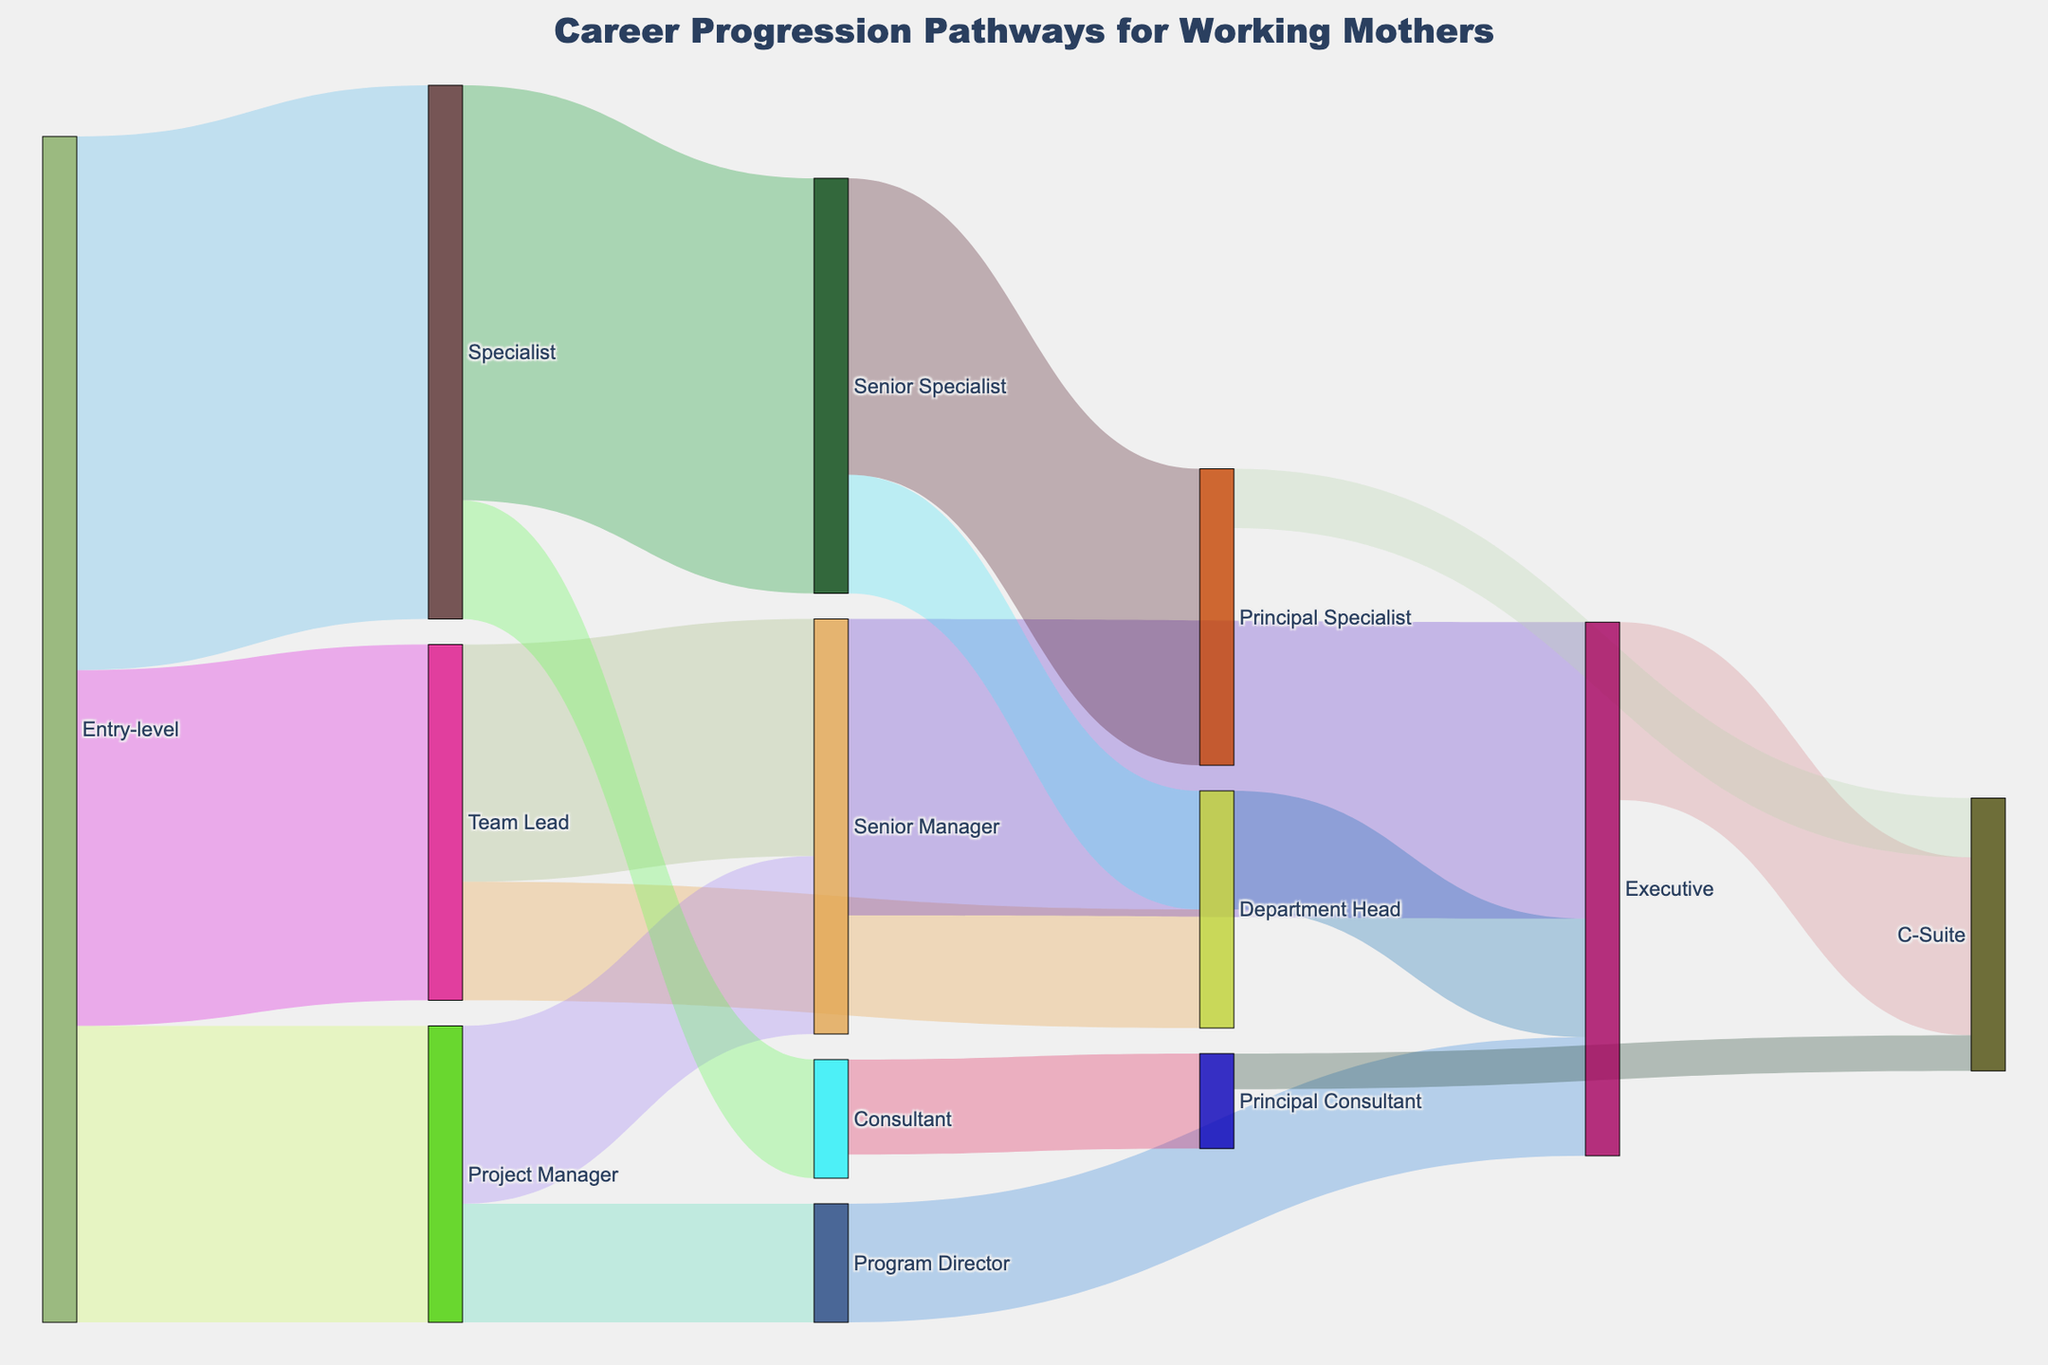what is the title of the figure? The title can be found at the top of the figure, typically placed centrally.
Answer: Career Progression Pathways for Working Mothers which career path from Entry-level has the most transitions? By looking at the thickness of the pathways from Entry-level, the Specialist path has the thickest line which indicates that it has the highest value.
Answer: Specialist How many working mothers transition from Specialist to Principal Specialist? Locate the pathway from Specialist to Principal Specialist and read the value associated with it.
Answer: 25 Which position ultimately leads to the highest number of transitions to the C-Suite? Compare the values of the transitions leading to the C-Suite from various preceding positions (Executive, Principal Specialist, Principal Consultant). The sum of transitions going through Executive to C-Suite is higher.
Answer: Executive how many total transitions lead to C-Suite positions? Sum the values of all transitions leading to C-Suite: from Executive (15), Principal Specialist (5), and Principal Consultant (3).
Answer: 23 Which path has more transitions: from Senior Specialist to Principal Specialist or from Specialist to Senior Specialist? Compare the values of the two paths. Senior Specialist to Principal Specialist has a value of 25, and Specialist to Senior Specialist has a value of 35.
Answer: Specialist to Senior Specialist What is the sum of transitions leading to an Executive position? Add the values for all pathways that end at Executive: Senior Manager (25), Department Head (10), and Program Director (10).
Answer: 45 Which transition has fewer values: from Team Lead to Department Head or from Project Manager to Program Director? Compare the values: Team Lead to Department Head has a value of 10, and Project Manager to Program Director has a value of 10. Both are equal.
Answer: Equal What is the total number of transitions from Project Manager to other positions? Sum the values for all transitions starting from Project Manager: Senior Manager (15) and Program Director (10).
Answer: 25 What percentage of the total transitions go from Entry-level to a Team Lead? Calculate the value from Entry-level to Team Lead (30) and divide by the total sum of all values from Entry-level paths (30 + 25 + 45). Then, multiply by 100. (30 / 100) * 100 = 30%
Answer: 30% 